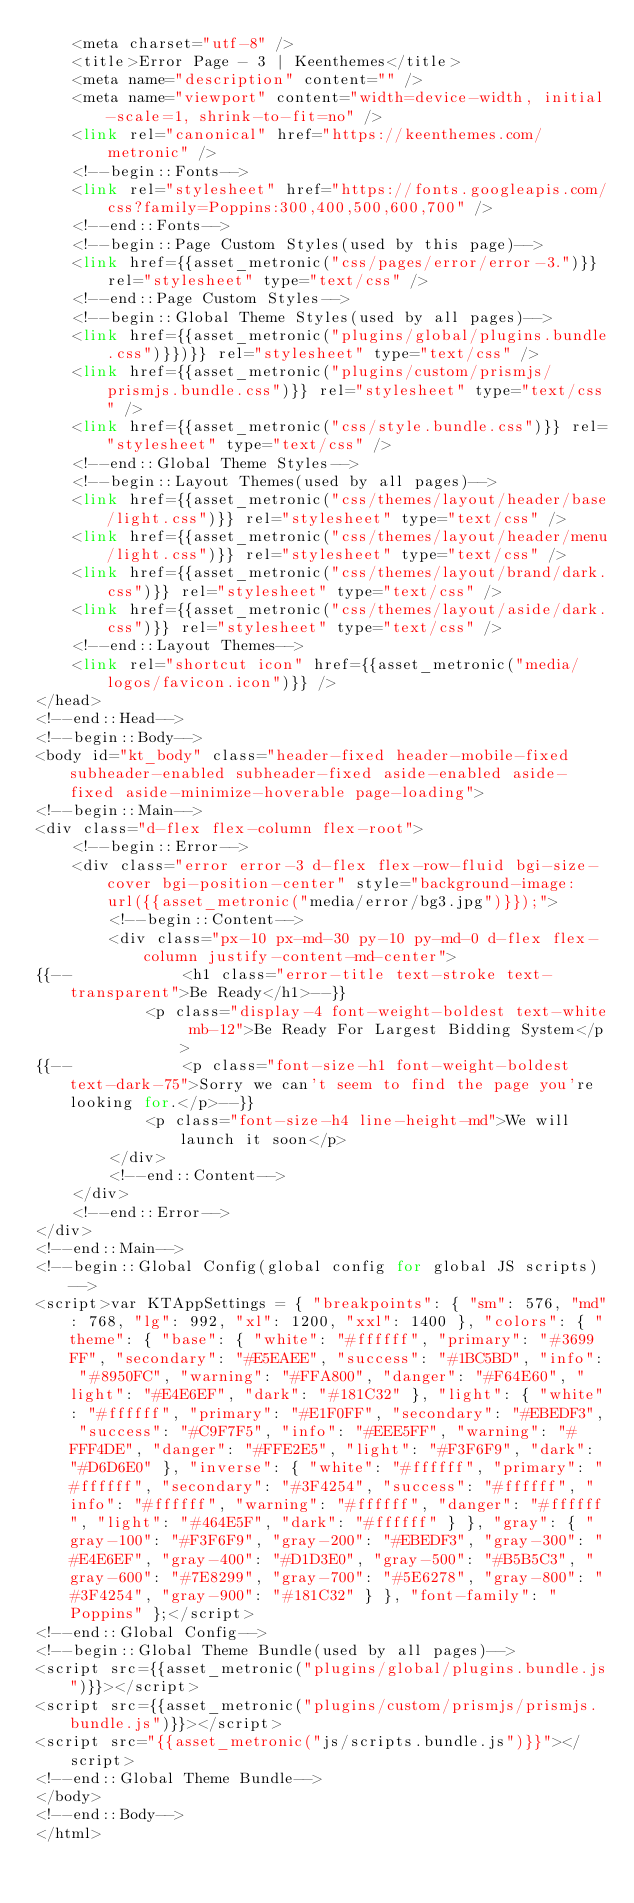Convert code to text. <code><loc_0><loc_0><loc_500><loc_500><_PHP_>    <meta charset="utf-8" />
    <title>Error Page - 3 | Keenthemes</title>
    <meta name="description" content="" />
    <meta name="viewport" content="width=device-width, initial-scale=1, shrink-to-fit=no" />
    <link rel="canonical" href="https://keenthemes.com/metronic" />
    <!--begin::Fonts-->
    <link rel="stylesheet" href="https://fonts.googleapis.com/css?family=Poppins:300,400,500,600,700" />
    <!--end::Fonts-->
    <!--begin::Page Custom Styles(used by this page)-->
    <link href={{asset_metronic("css/pages/error/error-3.")}} rel="stylesheet" type="text/css" />
    <!--end::Page Custom Styles-->
    <!--begin::Global Theme Styles(used by all pages)-->
    <link href={{asset_metronic("plugins/global/plugins.bundle.css")}})}} rel="stylesheet" type="text/css" />
    <link href={{asset_metronic("plugins/custom/prismjs/prismjs.bundle.css")}} rel="stylesheet" type="text/css" />
    <link href={{asset_metronic("css/style.bundle.css")}} rel="stylesheet" type="text/css" />
    <!--end::Global Theme Styles-->
    <!--begin::Layout Themes(used by all pages)-->
    <link href={{asset_metronic("css/themes/layout/header/base/light.css")}} rel="stylesheet" type="text/css" />
    <link href={{asset_metronic("css/themes/layout/header/menu/light.css")}} rel="stylesheet" type="text/css" />
    <link href={{asset_metronic("css/themes/layout/brand/dark.css")}} rel="stylesheet" type="text/css" />
    <link href={{asset_metronic("css/themes/layout/aside/dark.css")}} rel="stylesheet" type="text/css" />
    <!--end::Layout Themes-->
    <link rel="shortcut icon" href={{asset_metronic("media/logos/favicon.icon")}} />
</head>
<!--end::Head-->
<!--begin::Body-->
<body id="kt_body" class="header-fixed header-mobile-fixed subheader-enabled subheader-fixed aside-enabled aside-fixed aside-minimize-hoverable page-loading">
<!--begin::Main-->
<div class="d-flex flex-column flex-root">
    <!--begin::Error-->
    <div class="error error-3 d-flex flex-row-fluid bgi-size-cover bgi-position-center" style="background-image: url({{asset_metronic("media/error/bg3.jpg")}});">
        <!--begin::Content-->
        <div class="px-10 px-md-30 py-10 py-md-0 d-flex flex-column justify-content-md-center">
{{--            <h1 class="error-title text-stroke text-transparent">Be Ready</h1>--}}
            <p class="display-4 font-weight-boldest text-white mb-12">Be Ready For Largest Bidding System</p>
{{--            <p class="font-size-h1 font-weight-boldest text-dark-75">Sorry we can't seem to find the page you're looking for.</p>--}}
            <p class="font-size-h4 line-height-md">We will launch it soon</p>
        </div>
        <!--end::Content-->
    </div>
    <!--end::Error-->
</div>
<!--end::Main-->
<!--begin::Global Config(global config for global JS scripts)-->
<script>var KTAppSettings = { "breakpoints": { "sm": 576, "md": 768, "lg": 992, "xl": 1200, "xxl": 1400 }, "colors": { "theme": { "base": { "white": "#ffffff", "primary": "#3699FF", "secondary": "#E5EAEE", "success": "#1BC5BD", "info": "#8950FC", "warning": "#FFA800", "danger": "#F64E60", "light": "#E4E6EF", "dark": "#181C32" }, "light": { "white": "#ffffff", "primary": "#E1F0FF", "secondary": "#EBEDF3", "success": "#C9F7F5", "info": "#EEE5FF", "warning": "#FFF4DE", "danger": "#FFE2E5", "light": "#F3F6F9", "dark": "#D6D6E0" }, "inverse": { "white": "#ffffff", "primary": "#ffffff", "secondary": "#3F4254", "success": "#ffffff", "info": "#ffffff", "warning": "#ffffff", "danger": "#ffffff", "light": "#464E5F", "dark": "#ffffff" } }, "gray": { "gray-100": "#F3F6F9", "gray-200": "#EBEDF3", "gray-300": "#E4E6EF", "gray-400": "#D1D3E0", "gray-500": "#B5B5C3", "gray-600": "#7E8299", "gray-700": "#5E6278", "gray-800": "#3F4254", "gray-900": "#181C32" } }, "font-family": "Poppins" };</script>
<!--end::Global Config-->
<!--begin::Global Theme Bundle(used by all pages)-->
<script src={{asset_metronic("plugins/global/plugins.bundle.js")}}></script>
<script src={{asset_metronic("plugins/custom/prismjs/prismjs.bundle.js")}}></script>
<script src="{{asset_metronic("js/scripts.bundle.js")}}"></script>
<!--end::Global Theme Bundle-->
</body>
<!--end::Body-->
</html>
</code> 